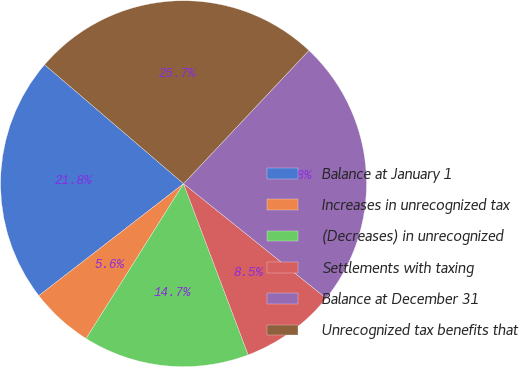<chart> <loc_0><loc_0><loc_500><loc_500><pie_chart><fcel>Balance at January 1<fcel>Increases in unrecognized tax<fcel>(Decreases) in unrecognized<fcel>Settlements with taxing<fcel>Balance at December 31<fcel>Unrecognized tax benefits that<nl><fcel>21.75%<fcel>5.58%<fcel>14.68%<fcel>8.48%<fcel>23.75%<fcel>25.74%<nl></chart> 